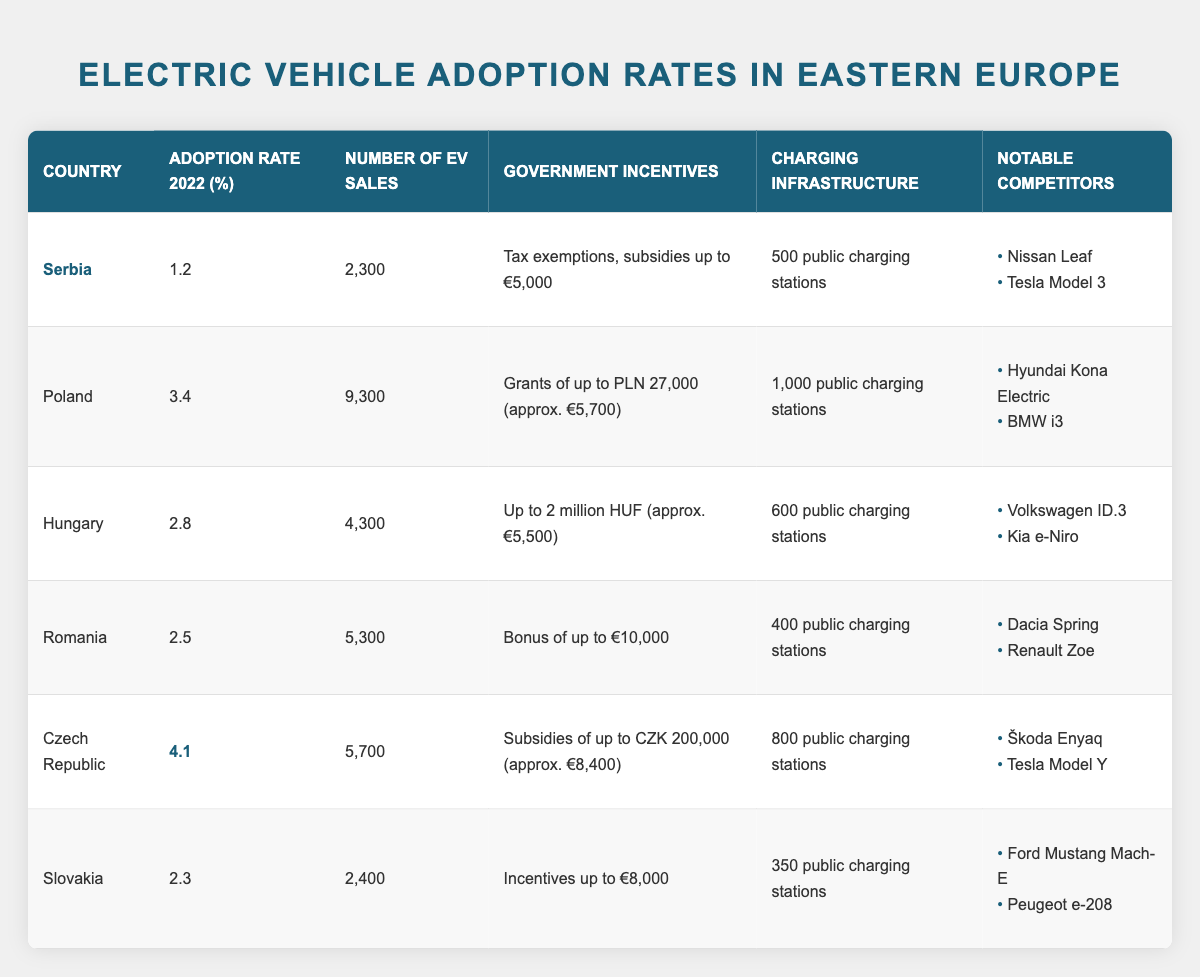What is the adoption rate of electric vehicles in Serbia for 2022? The adoption rate for Serbia is found directly in the table under the respective column, which lists it as 1.2%.
Answer: 1.2% How many electric vehicles were sold in Poland in 2022? The number of EV sales in Poland is directly listed in the table, which states that 9,300 electric vehicles were sold.
Answer: 9,300 Which country has the highest adoption rate of electric vehicles in 2022? By comparing the adoption rates in the table, it is clear that the Czech Republic has the highest rate at 4.1%.
Answer: Czech Republic What government incentive does Hungary offer for electric vehicle purchases? The table specifies that Hungary offers incentives of up to 2 million HUF or approximately €5,500 for EV purchases.
Answer: Up to 2 million HUF (approx. €5,500) Calculate the average adoption rate of electric vehicles for the listed countries. To find the average, sum the adoption rates (1.2 + 3.4 + 2.8 + 2.5 + 4.1 + 2.3 = 16.3) and then divide by the number of countries (6), yielding 16.3 / 6 = 2.72%.
Answer: 2.72% Does Romania have more EV sales than Slovakia? The table indicates Romania with 5,300 EV sales and Slovakia with 2,400 EV sales, confirming that Romania has more sales.
Answer: Yes What is the difference between the number of EV sales in Poland and Hungary? The number of EV sales in Poland is 9,300 and in Hungary is 4,300. The difference is calculated as 9,300 - 4,300 = 5,000.
Answer: 5,000 Which country has the lowest number of public charging stations? By looking at the charging infrastructure column, Slovakia has the lowest number with 350 public charging stations.
Answer: Slovakia If you combine the number of EV sales from Serbia and Slovakia, how many would that be? Serbia has 2,300 EV sales and Slovakia has 2,400. Adding them together gives 2,300 + 2,400 = 4,700.
Answer: 4,700 What notable competitors does the Czech Republic have for electric vehicles? The table lists the notable competitors for the Czech Republic as Škoda Enyaq and Tesla Model Y.
Answer: Škoda Enyaq, Tesla Model Y Can you identify which country has the most substantial government incentives for electric vehicles? By reviewing the table, the Czech Republic offers the most significant subsidies of up to CZK 200,000, approximately €8,400.
Answer: Czech Republic 